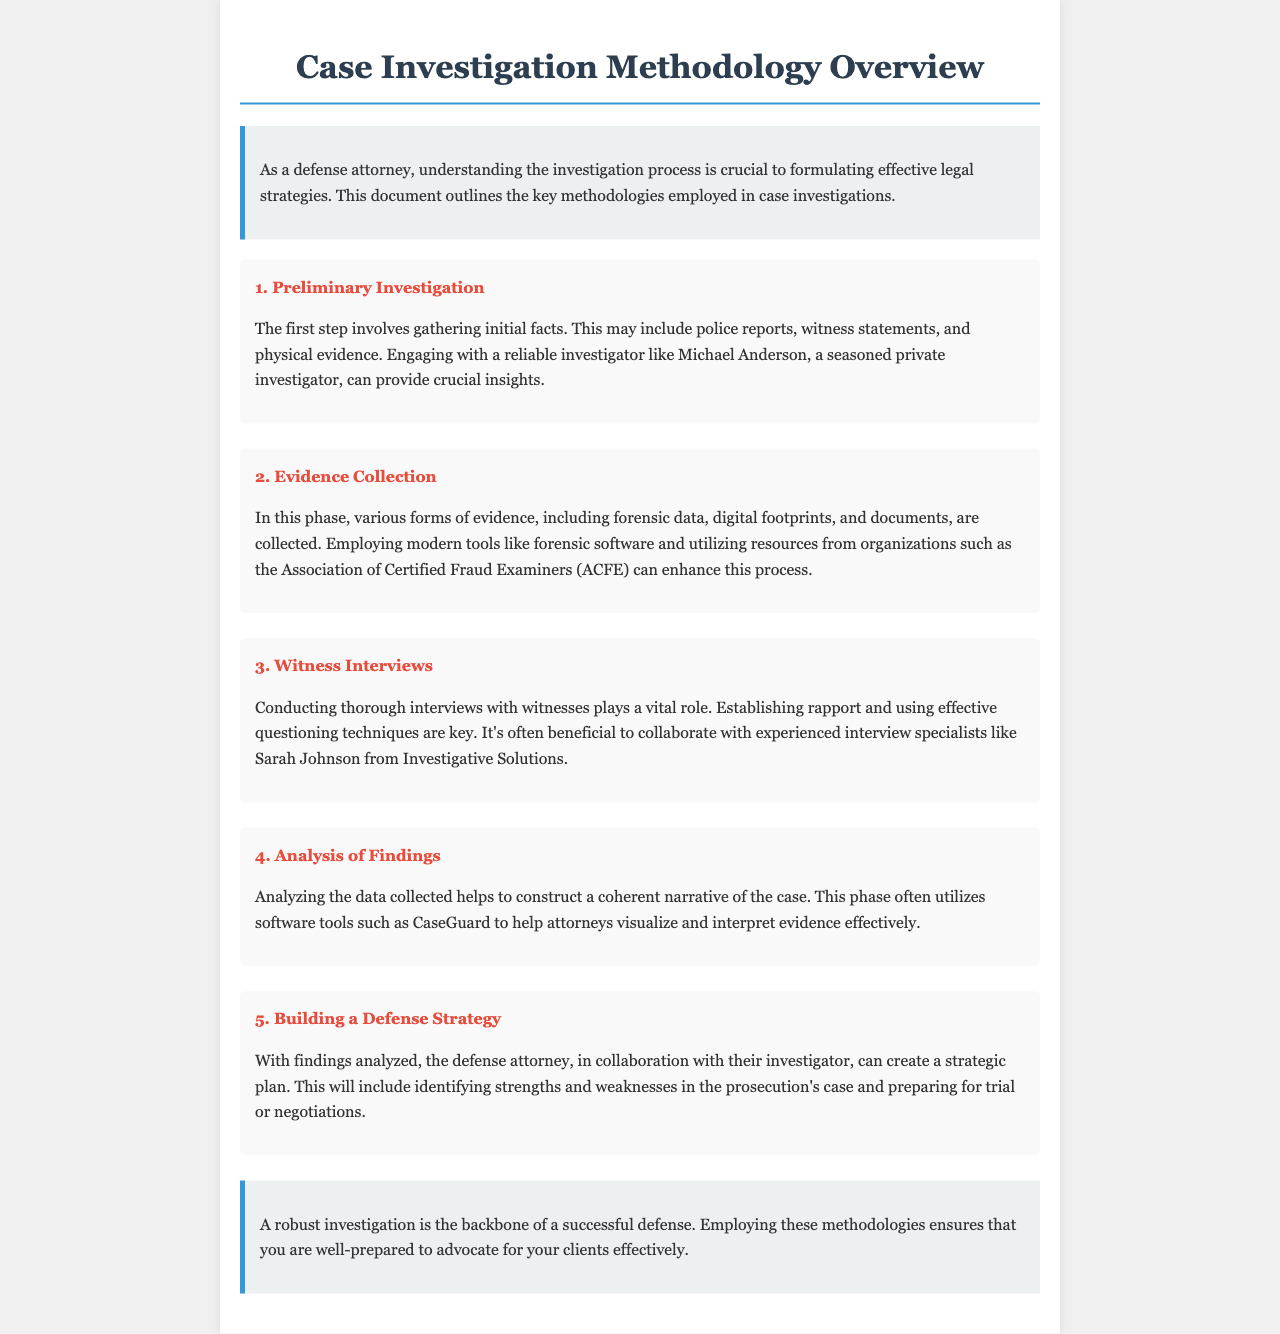What is the main purpose of the brochure? The brochure outlines the key methodologies employed in case investigations.
Answer: To outline key methodologies Who is mentioned as a reliable investigator? Michael Anderson is introduced as a seasoned private investigator.
Answer: Michael Anderson What software is mentioned for analyzing findings? The document refers to CaseGuard as a software tool for analysis.
Answer: CaseGuard What is the first step in the investigation process? The initial step involves gathering initial facts, including police reports.
Answer: Preliminary Investigation Which organization is referenced for enhancing the evidence collection process? The brochure mentions the Association of Certified Fraud Examiners (ACFE).
Answer: Association of Certified Fraud Examiners What role do witness interviews play in case investigations? Witness interviews are vital for establishing rapport and effective questioning.
Answer: Vital How does analyzing findings help attorneys? Analyzing findings helps construct a coherent narrative of the case.
Answer: Construct a coherent narrative Who is suggested for collaboration in conducting witness interviews? Sarah Johnson is mentioned as an experienced interview specialist.
Answer: Sarah Johnson What outcome is aimed for in building a defense strategy? The goal is to identify strengths and weaknesses in the prosecution's case.
Answer: Identify strengths and weaknesses 